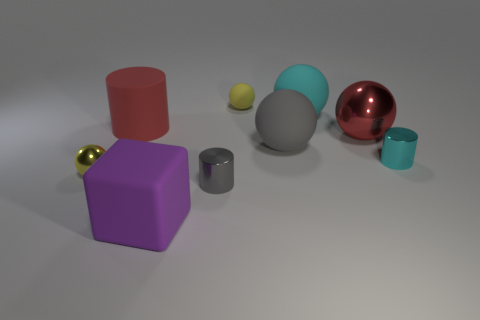Subtract all red spheres. How many spheres are left? 4 Subtract all red balls. How many balls are left? 4 Subtract all brown spheres. Subtract all yellow cylinders. How many spheres are left? 5 Add 1 big red metallic balls. How many objects exist? 10 Subtract all balls. How many objects are left? 4 Subtract 0 yellow blocks. How many objects are left? 9 Subtract all small purple metallic blocks. Subtract all red matte cylinders. How many objects are left? 8 Add 9 large purple matte objects. How many large purple matte objects are left? 10 Add 1 big brown objects. How many big brown objects exist? 1 